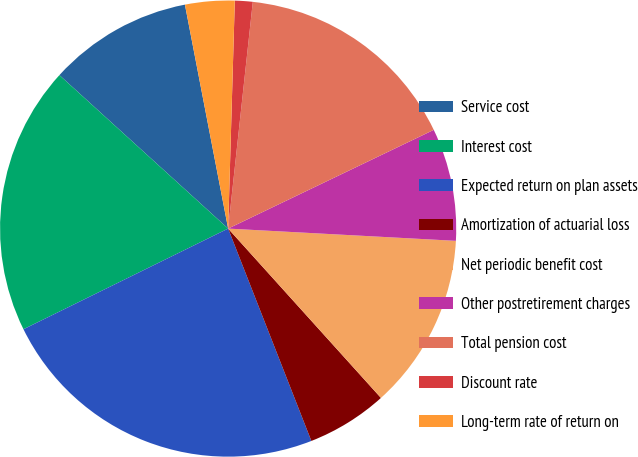Convert chart to OTSL. <chart><loc_0><loc_0><loc_500><loc_500><pie_chart><fcel>Service cost<fcel>Interest cost<fcel>Expected return on plan assets<fcel>Amortization of actuarial loss<fcel>Net periodic benefit cost<fcel>Other postretirement charges<fcel>Total pension cost<fcel>Discount rate<fcel>Long-term rate of return on<nl><fcel>10.22%<fcel>19.02%<fcel>23.67%<fcel>5.74%<fcel>12.46%<fcel>7.98%<fcel>16.15%<fcel>1.26%<fcel>3.5%<nl></chart> 